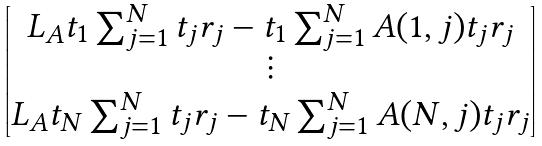<formula> <loc_0><loc_0><loc_500><loc_500>\begin{bmatrix} L _ { A } t _ { 1 } \sum _ { j = 1 } ^ { N } t _ { j } r _ { j } - t _ { 1 } \sum _ { j = 1 } ^ { N } A ( 1 , j ) t _ { j } r _ { j } \\ \vdots \\ L _ { A } t _ { N } \sum _ { j = 1 } ^ { N } t _ { j } r _ { j } - t _ { N } \sum _ { j = 1 } ^ { N } A ( N , j ) t _ { j } r _ { j } \\ \end{bmatrix}</formula> 